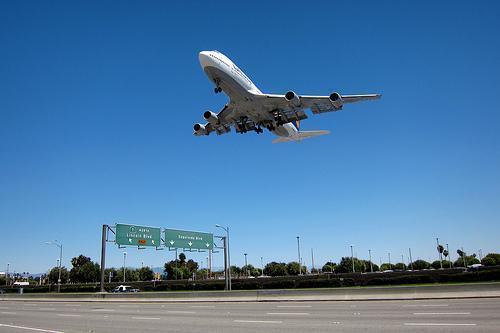How many cars are on the highway?
Give a very brief answer. 0. How many planes do you see?
Give a very brief answer. 1. 